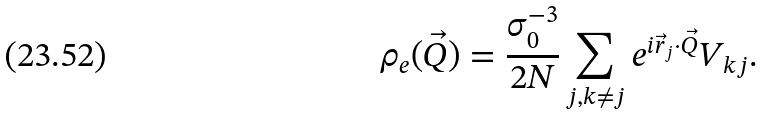Convert formula to latex. <formula><loc_0><loc_0><loc_500><loc_500>\rho _ { e } ( \vec { Q } ) = \frac { \sigma _ { 0 } ^ { - 3 } } { 2 N } \sum _ { j , k \neq j } e ^ { i \vec { r } _ { j } \cdot \vec { Q } } V _ { k j } .</formula> 